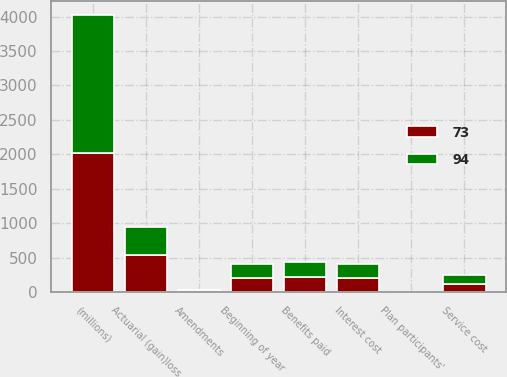<chart> <loc_0><loc_0><loc_500><loc_500><stacked_bar_chart><ecel><fcel>(millions)<fcel>Beginning of year<fcel>Service cost<fcel>Interest cost<fcel>Plan participants'<fcel>Amendments<fcel>Actuarial (gain)loss<fcel>Benefits paid<nl><fcel>94<fcel>2013<fcel>205<fcel>133<fcel>203<fcel>2<fcel>4<fcel>407<fcel>218<nl><fcel>73<fcel>2012<fcel>205<fcel>110<fcel>207<fcel>2<fcel>23<fcel>535<fcel>213<nl></chart> 